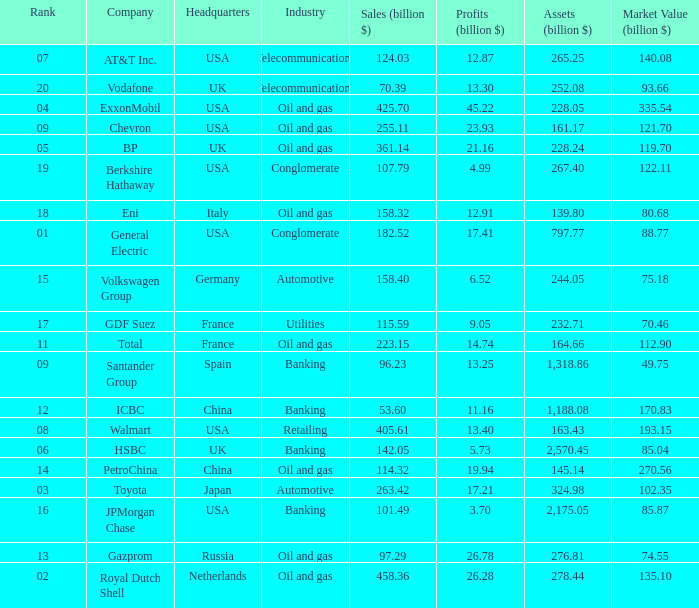How many Assets (billion $) has an Industry of oil and gas, and a Rank of 9, and a Market Value (billion $) larger than 121.7? None. Could you parse the entire table? {'header': ['Rank', 'Company', 'Headquarters', 'Industry', 'Sales (billion $)', 'Profits (billion $)', 'Assets (billion $)', 'Market Value (billion $)'], 'rows': [['07', 'AT&T Inc.', 'USA', 'Telecommunications', '124.03', '12.87', '265.25', '140.08'], ['20', 'Vodafone', 'UK', 'Telecommunications', '70.39', '13.30', '252.08', '93.66'], ['04', 'ExxonMobil', 'USA', 'Oil and gas', '425.70', '45.22', '228.05', '335.54'], ['09', 'Chevron', 'USA', 'Oil and gas', '255.11', '23.93', '161.17', '121.70'], ['05', 'BP', 'UK', 'Oil and gas', '361.14', '21.16', '228.24', '119.70'], ['19', 'Berkshire Hathaway', 'USA', 'Conglomerate', '107.79', '4.99', '267.40', '122.11'], ['18', 'Eni', 'Italy', 'Oil and gas', '158.32', '12.91', '139.80', '80.68'], ['01', 'General Electric', 'USA', 'Conglomerate', '182.52', '17.41', '797.77', '88.77'], ['15', 'Volkswagen Group', 'Germany', 'Automotive', '158.40', '6.52', '244.05', '75.18'], ['17', 'GDF Suez', 'France', 'Utilities', '115.59', '9.05', '232.71', '70.46'], ['11', 'Total', 'France', 'Oil and gas', '223.15', '14.74', '164.66', '112.90'], ['09', 'Santander Group', 'Spain', 'Banking', '96.23', '13.25', '1,318.86', '49.75'], ['12', 'ICBC', 'China', 'Banking', '53.60', '11.16', '1,188.08', '170.83'], ['08', 'Walmart', 'USA', 'Retailing', '405.61', '13.40', '163.43', '193.15'], ['06', 'HSBC', 'UK', 'Banking', '142.05', '5.73', '2,570.45', '85.04'], ['14', 'PetroChina', 'China', 'Oil and gas', '114.32', '19.94', '145.14', '270.56'], ['03', 'Toyota', 'Japan', 'Automotive', '263.42', '17.21', '324.98', '102.35'], ['16', 'JPMorgan Chase', 'USA', 'Banking', '101.49', '3.70', '2,175.05', '85.87'], ['13', 'Gazprom', 'Russia', 'Oil and gas', '97.29', '26.78', '276.81', '74.55'], ['02', 'Royal Dutch Shell', 'Netherlands', 'Oil and gas', '458.36', '26.28', '278.44', '135.10']]} 